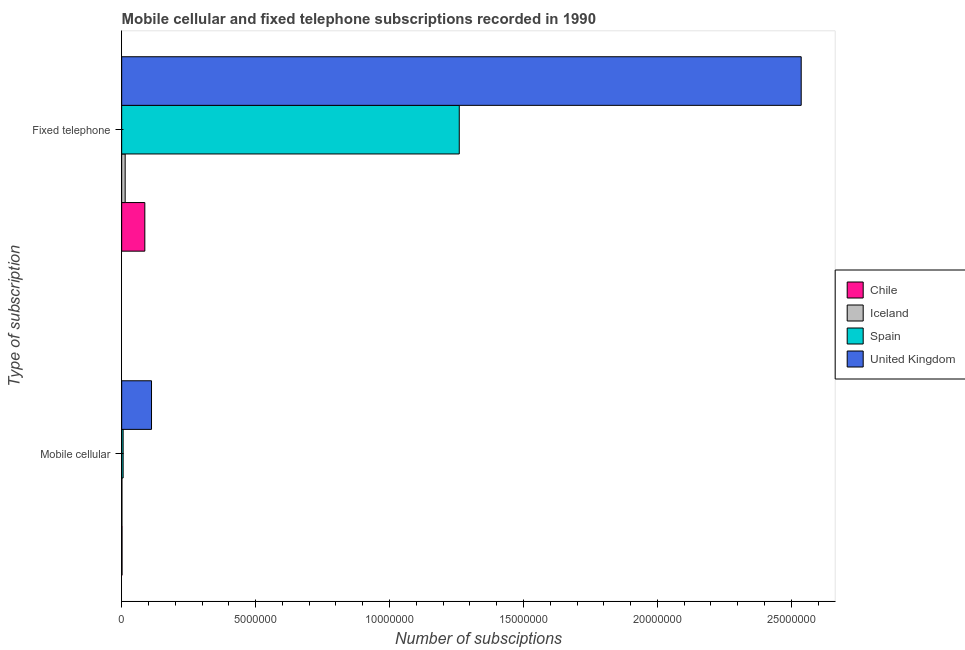Are the number of bars per tick equal to the number of legend labels?
Provide a short and direct response. Yes. How many bars are there on the 1st tick from the top?
Your answer should be compact. 4. What is the label of the 2nd group of bars from the top?
Your answer should be very brief. Mobile cellular. What is the number of mobile cellular subscriptions in United Kingdom?
Offer a very short reply. 1.11e+06. Across all countries, what is the maximum number of mobile cellular subscriptions?
Give a very brief answer. 1.11e+06. Across all countries, what is the minimum number of fixed telephone subscriptions?
Offer a very short reply. 1.30e+05. In which country was the number of mobile cellular subscriptions maximum?
Make the answer very short. United Kingdom. What is the total number of mobile cellular subscriptions in the graph?
Provide a succinct answer. 1.19e+06. What is the difference between the number of mobile cellular subscriptions in United Kingdom and that in Iceland?
Keep it short and to the point. 1.10e+06. What is the difference between the number of fixed telephone subscriptions in Chile and the number of mobile cellular subscriptions in Iceland?
Ensure brevity in your answer.  8.54e+05. What is the average number of mobile cellular subscriptions per country?
Ensure brevity in your answer.  2.98e+05. What is the difference between the number of mobile cellular subscriptions and number of fixed telephone subscriptions in Spain?
Offer a terse response. -1.25e+07. In how many countries, is the number of fixed telephone subscriptions greater than 22000000 ?
Make the answer very short. 1. What is the ratio of the number of mobile cellular subscriptions in Iceland to that in Chile?
Offer a very short reply. 0.72. Is the number of mobile cellular subscriptions in Chile less than that in United Kingdom?
Your answer should be compact. Yes. In how many countries, is the number of mobile cellular subscriptions greater than the average number of mobile cellular subscriptions taken over all countries?
Keep it short and to the point. 1. Are all the bars in the graph horizontal?
Your response must be concise. Yes. What is the difference between two consecutive major ticks on the X-axis?
Your answer should be very brief. 5.00e+06. Does the graph contain any zero values?
Keep it short and to the point. No. How are the legend labels stacked?
Make the answer very short. Vertical. What is the title of the graph?
Make the answer very short. Mobile cellular and fixed telephone subscriptions recorded in 1990. Does "Middle East & North Africa (developing only)" appear as one of the legend labels in the graph?
Make the answer very short. No. What is the label or title of the X-axis?
Your answer should be compact. Number of subsciptions. What is the label or title of the Y-axis?
Provide a succinct answer. Type of subscription. What is the Number of subsciptions in Chile in Mobile cellular?
Keep it short and to the point. 1.39e+04. What is the Number of subsciptions of Iceland in Mobile cellular?
Your answer should be very brief. 1.00e+04. What is the Number of subsciptions in Spain in Mobile cellular?
Provide a succinct answer. 5.47e+04. What is the Number of subsciptions of United Kingdom in Mobile cellular?
Ensure brevity in your answer.  1.11e+06. What is the Number of subsciptions of Chile in Fixed telephone?
Provide a succinct answer. 8.64e+05. What is the Number of subsciptions in Iceland in Fixed telephone?
Ensure brevity in your answer.  1.30e+05. What is the Number of subsciptions of Spain in Fixed telephone?
Your response must be concise. 1.26e+07. What is the Number of subsciptions of United Kingdom in Fixed telephone?
Keep it short and to the point. 2.54e+07. Across all Type of subscription, what is the maximum Number of subsciptions of Chile?
Provide a short and direct response. 8.64e+05. Across all Type of subscription, what is the maximum Number of subsciptions of Iceland?
Provide a succinct answer. 1.30e+05. Across all Type of subscription, what is the maximum Number of subsciptions of Spain?
Your answer should be compact. 1.26e+07. Across all Type of subscription, what is the maximum Number of subsciptions of United Kingdom?
Your answer should be very brief. 2.54e+07. Across all Type of subscription, what is the minimum Number of subsciptions in Chile?
Offer a very short reply. 1.39e+04. Across all Type of subscription, what is the minimum Number of subsciptions in Iceland?
Provide a succinct answer. 1.00e+04. Across all Type of subscription, what is the minimum Number of subsciptions in Spain?
Offer a very short reply. 5.47e+04. Across all Type of subscription, what is the minimum Number of subsciptions of United Kingdom?
Make the answer very short. 1.11e+06. What is the total Number of subsciptions in Chile in the graph?
Your answer should be very brief. 8.78e+05. What is the total Number of subsciptions of Iceland in the graph?
Offer a terse response. 1.40e+05. What is the total Number of subsciptions of Spain in the graph?
Your answer should be very brief. 1.27e+07. What is the total Number of subsciptions in United Kingdom in the graph?
Your response must be concise. 2.65e+07. What is the difference between the Number of subsciptions of Chile in Mobile cellular and that in Fixed telephone?
Give a very brief answer. -8.50e+05. What is the difference between the Number of subsciptions of Iceland in Mobile cellular and that in Fixed telephone?
Offer a terse response. -1.20e+05. What is the difference between the Number of subsciptions of Spain in Mobile cellular and that in Fixed telephone?
Give a very brief answer. -1.25e+07. What is the difference between the Number of subsciptions in United Kingdom in Mobile cellular and that in Fixed telephone?
Keep it short and to the point. -2.43e+07. What is the difference between the Number of subsciptions in Chile in Mobile cellular and the Number of subsciptions in Iceland in Fixed telephone?
Offer a very short reply. -1.17e+05. What is the difference between the Number of subsciptions in Chile in Mobile cellular and the Number of subsciptions in Spain in Fixed telephone?
Provide a short and direct response. -1.26e+07. What is the difference between the Number of subsciptions of Chile in Mobile cellular and the Number of subsciptions of United Kingdom in Fixed telephone?
Your answer should be very brief. -2.54e+07. What is the difference between the Number of subsciptions of Iceland in Mobile cellular and the Number of subsciptions of Spain in Fixed telephone?
Provide a short and direct response. -1.26e+07. What is the difference between the Number of subsciptions in Iceland in Mobile cellular and the Number of subsciptions in United Kingdom in Fixed telephone?
Ensure brevity in your answer.  -2.54e+07. What is the difference between the Number of subsciptions in Spain in Mobile cellular and the Number of subsciptions in United Kingdom in Fixed telephone?
Offer a terse response. -2.53e+07. What is the average Number of subsciptions in Chile per Type of subscription?
Your answer should be compact. 4.39e+05. What is the average Number of subsciptions of Iceland per Type of subscription?
Your response must be concise. 7.02e+04. What is the average Number of subsciptions of Spain per Type of subscription?
Provide a short and direct response. 6.33e+06. What is the average Number of subsciptions in United Kingdom per Type of subscription?
Offer a very short reply. 1.32e+07. What is the difference between the Number of subsciptions in Chile and Number of subsciptions in Iceland in Mobile cellular?
Offer a terse response. 3911. What is the difference between the Number of subsciptions in Chile and Number of subsciptions in Spain in Mobile cellular?
Ensure brevity in your answer.  -4.08e+04. What is the difference between the Number of subsciptions in Chile and Number of subsciptions in United Kingdom in Mobile cellular?
Offer a terse response. -1.10e+06. What is the difference between the Number of subsciptions of Iceland and Number of subsciptions of Spain in Mobile cellular?
Your answer should be compact. -4.47e+04. What is the difference between the Number of subsciptions in Iceland and Number of subsciptions in United Kingdom in Mobile cellular?
Ensure brevity in your answer.  -1.10e+06. What is the difference between the Number of subsciptions of Spain and Number of subsciptions of United Kingdom in Mobile cellular?
Provide a succinct answer. -1.06e+06. What is the difference between the Number of subsciptions of Chile and Number of subsciptions of Iceland in Fixed telephone?
Give a very brief answer. 7.34e+05. What is the difference between the Number of subsciptions of Chile and Number of subsciptions of Spain in Fixed telephone?
Provide a short and direct response. -1.17e+07. What is the difference between the Number of subsciptions in Chile and Number of subsciptions in United Kingdom in Fixed telephone?
Give a very brief answer. -2.45e+07. What is the difference between the Number of subsciptions of Iceland and Number of subsciptions of Spain in Fixed telephone?
Provide a succinct answer. -1.25e+07. What is the difference between the Number of subsciptions of Iceland and Number of subsciptions of United Kingdom in Fixed telephone?
Make the answer very short. -2.52e+07. What is the difference between the Number of subsciptions in Spain and Number of subsciptions in United Kingdom in Fixed telephone?
Provide a short and direct response. -1.28e+07. What is the ratio of the Number of subsciptions of Chile in Mobile cellular to that in Fixed telephone?
Offer a terse response. 0.02. What is the ratio of the Number of subsciptions of Iceland in Mobile cellular to that in Fixed telephone?
Offer a very short reply. 0.08. What is the ratio of the Number of subsciptions of Spain in Mobile cellular to that in Fixed telephone?
Make the answer very short. 0. What is the ratio of the Number of subsciptions in United Kingdom in Mobile cellular to that in Fixed telephone?
Provide a succinct answer. 0.04. What is the difference between the highest and the second highest Number of subsciptions of Chile?
Offer a terse response. 8.50e+05. What is the difference between the highest and the second highest Number of subsciptions of Iceland?
Provide a short and direct response. 1.20e+05. What is the difference between the highest and the second highest Number of subsciptions in Spain?
Your answer should be very brief. 1.25e+07. What is the difference between the highest and the second highest Number of subsciptions in United Kingdom?
Provide a short and direct response. 2.43e+07. What is the difference between the highest and the lowest Number of subsciptions of Chile?
Your answer should be very brief. 8.50e+05. What is the difference between the highest and the lowest Number of subsciptions in Iceland?
Offer a very short reply. 1.20e+05. What is the difference between the highest and the lowest Number of subsciptions of Spain?
Your response must be concise. 1.25e+07. What is the difference between the highest and the lowest Number of subsciptions in United Kingdom?
Ensure brevity in your answer.  2.43e+07. 